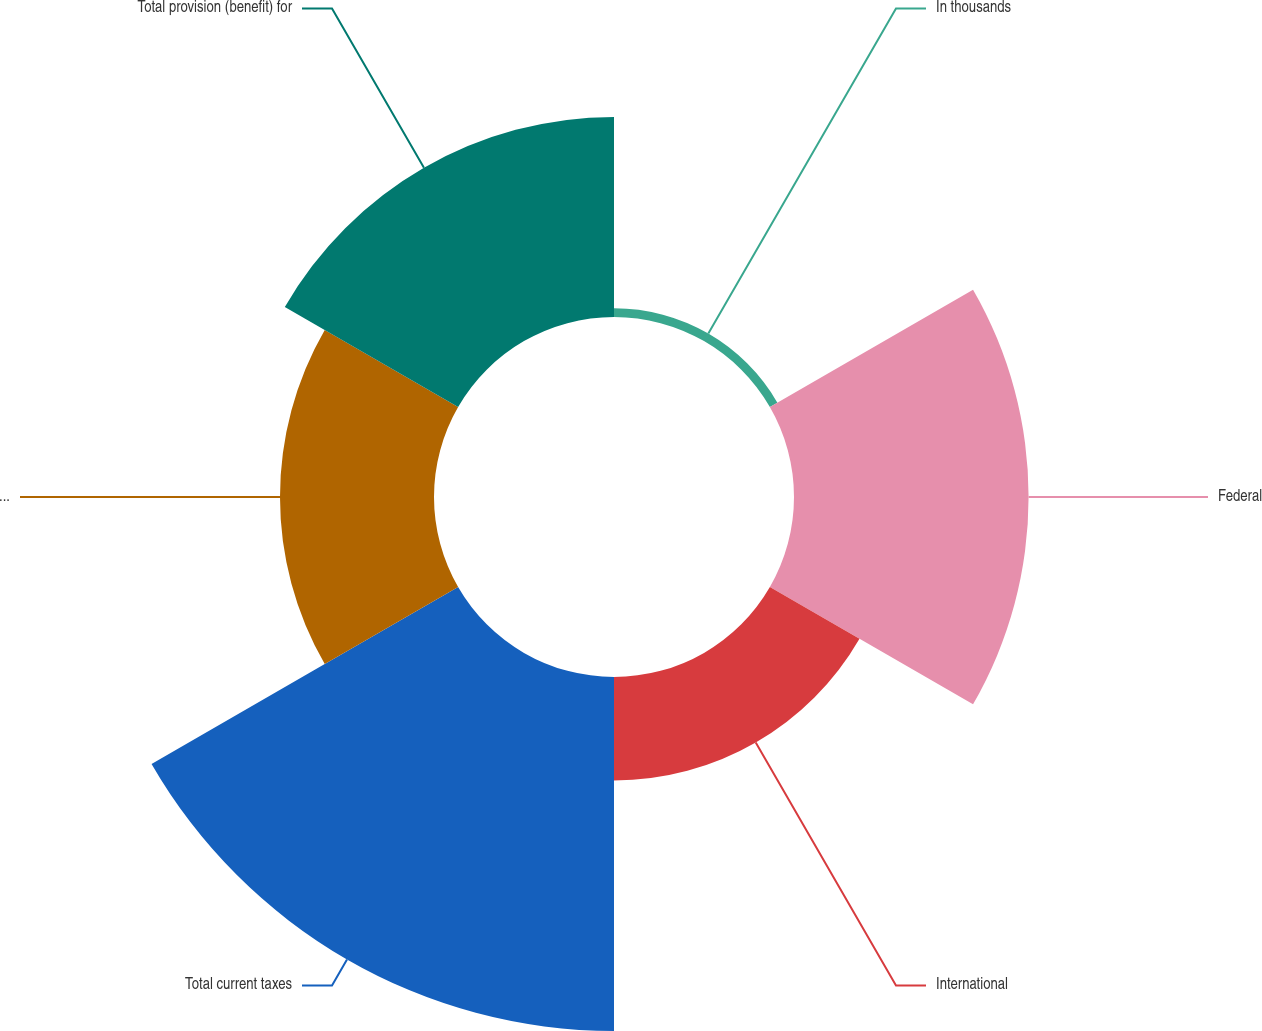Convert chart. <chart><loc_0><loc_0><loc_500><loc_500><pie_chart><fcel>In thousands<fcel>Federal<fcel>International<fcel>Total current taxes<fcel>Total deferred taxes<fcel>Total provision (benefit) for<nl><fcel>0.82%<fcel>22.24%<fcel>9.81%<fcel>33.56%<fcel>14.6%<fcel>18.97%<nl></chart> 